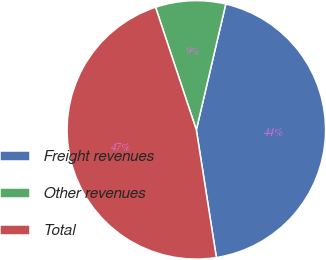Convert chart. <chart><loc_0><loc_0><loc_500><loc_500><pie_chart><fcel>Freight revenues<fcel>Other revenues<fcel>Total<nl><fcel>43.86%<fcel>8.77%<fcel>47.37%<nl></chart> 